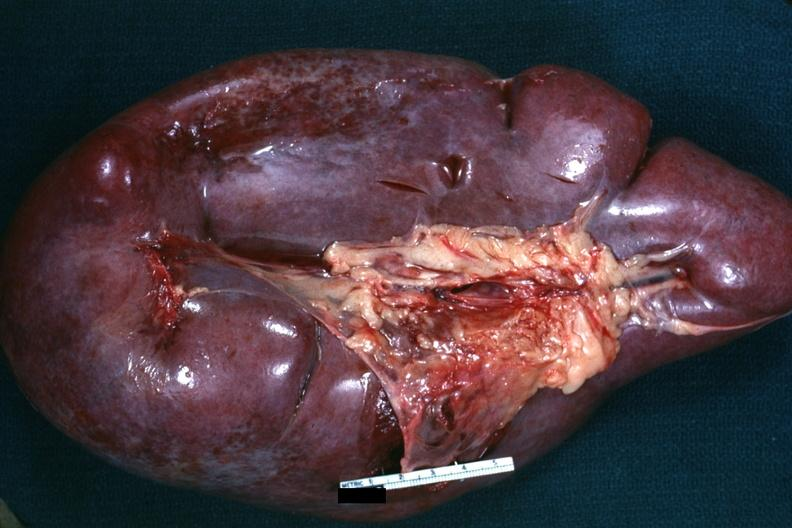s hematologic present?
Answer the question using a single word or phrase. Yes 